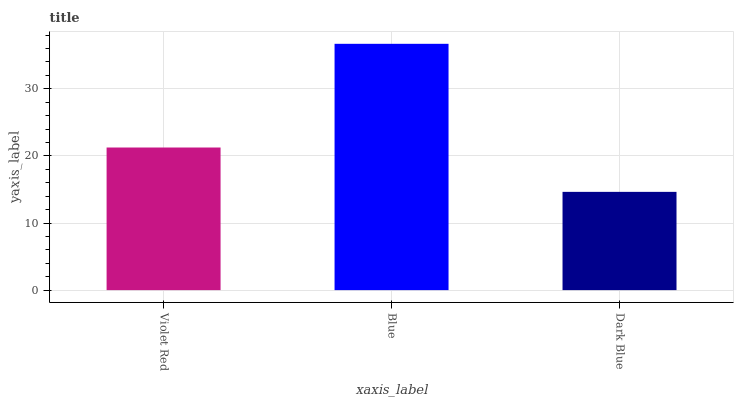Is Dark Blue the minimum?
Answer yes or no. Yes. Is Blue the maximum?
Answer yes or no. Yes. Is Blue the minimum?
Answer yes or no. No. Is Dark Blue the maximum?
Answer yes or no. No. Is Blue greater than Dark Blue?
Answer yes or no. Yes. Is Dark Blue less than Blue?
Answer yes or no. Yes. Is Dark Blue greater than Blue?
Answer yes or no. No. Is Blue less than Dark Blue?
Answer yes or no. No. Is Violet Red the high median?
Answer yes or no. Yes. Is Violet Red the low median?
Answer yes or no. Yes. Is Blue the high median?
Answer yes or no. No. Is Blue the low median?
Answer yes or no. No. 